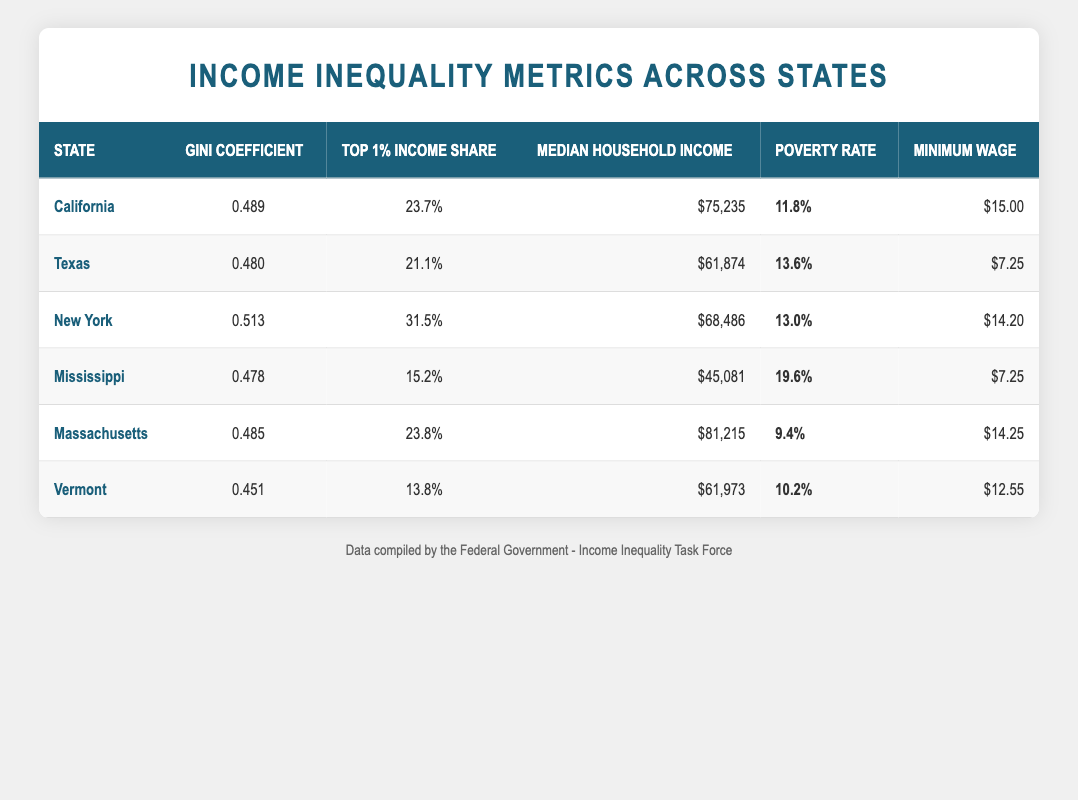What is the Gini Coefficient for New York? By looking at the row for New York in the table, I can see that the Gini Coefficient is listed as 0.513.
Answer: 0.513 Which state has the highest Top 1% Income Share? I compare the Top 1% Income Share values listed for each state. New York has the highest value of 31.5%.
Answer: New York What is the Median Household Income for Massachusetts? From the table, the Median Household Income for Massachusetts is listed as $81,215.
Answer: $81,215 Which state has a Minimum Wage higher than $15? I check the Minimum Wage column for each state. California and Massachusetts have Minimum Wages of $15.00 and $14.25, respectively. Therefore, California is the only state listed with a Minimum Wage higher than $15.
Answer: Yes, California What is the average Poverty Rate across all states in the table? I need to sum the Poverty Rates and then divide by the number of states. The sum is (11.8 + 13.6 + 13 + 19.6 + 9.4 + 10.2) = 87.6, and there are 6 states, so the average Poverty Rate is 87.6 / 6 = 14.6%.
Answer: 14.6% Is the Median Household Income for Texas greater than that for Mississippi? I look at the Median Household Income for both states: Texas has $61,874 and Mississippi has $45,081. Since $61,874 is greater than $45,081, the statement is true.
Answer: Yes What is the difference in the Gini Coefficient between California and Vermont? The Gini Coefficient for California is 0.489, and for Vermont, it is 0.451. The difference is 0.489 - 0.451 = 0.038.
Answer: 0.038 How does the poverty rate in California compare to that in Vermont? I check the Poverty Rates for both states: California has a rate of 11.8%, while Vermont has 10.2%. Since 11.8% is greater than 10.2%, California has a higher poverty rate.
Answer: California has a higher poverty rate What is the total Top 1% Income Share for all states combined? I add the Top 1% Income Share percentages for all states: (23.7 + 21.1 + 31.5 + 15.2 + 23.8 + 13.8) = 129.1%.
Answer: 129.1% 